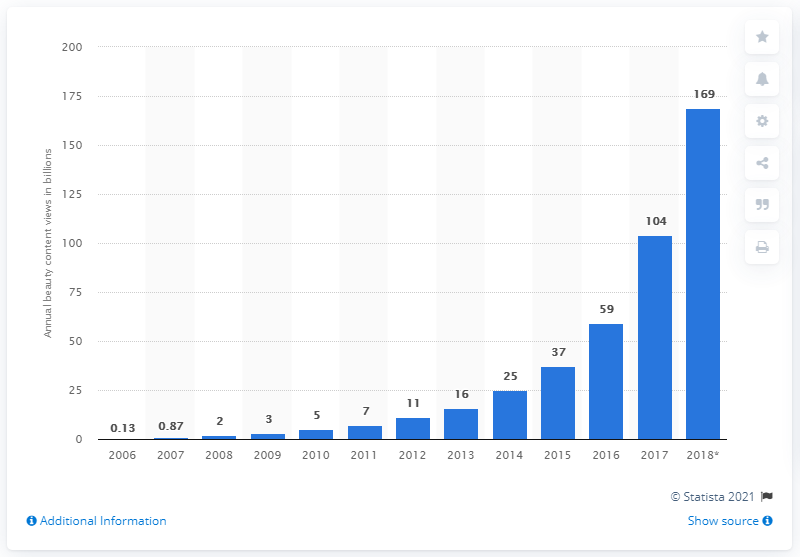Specify some key components in this picture. In 2018, beauty videos generated a total of 169 views on YouTube. 